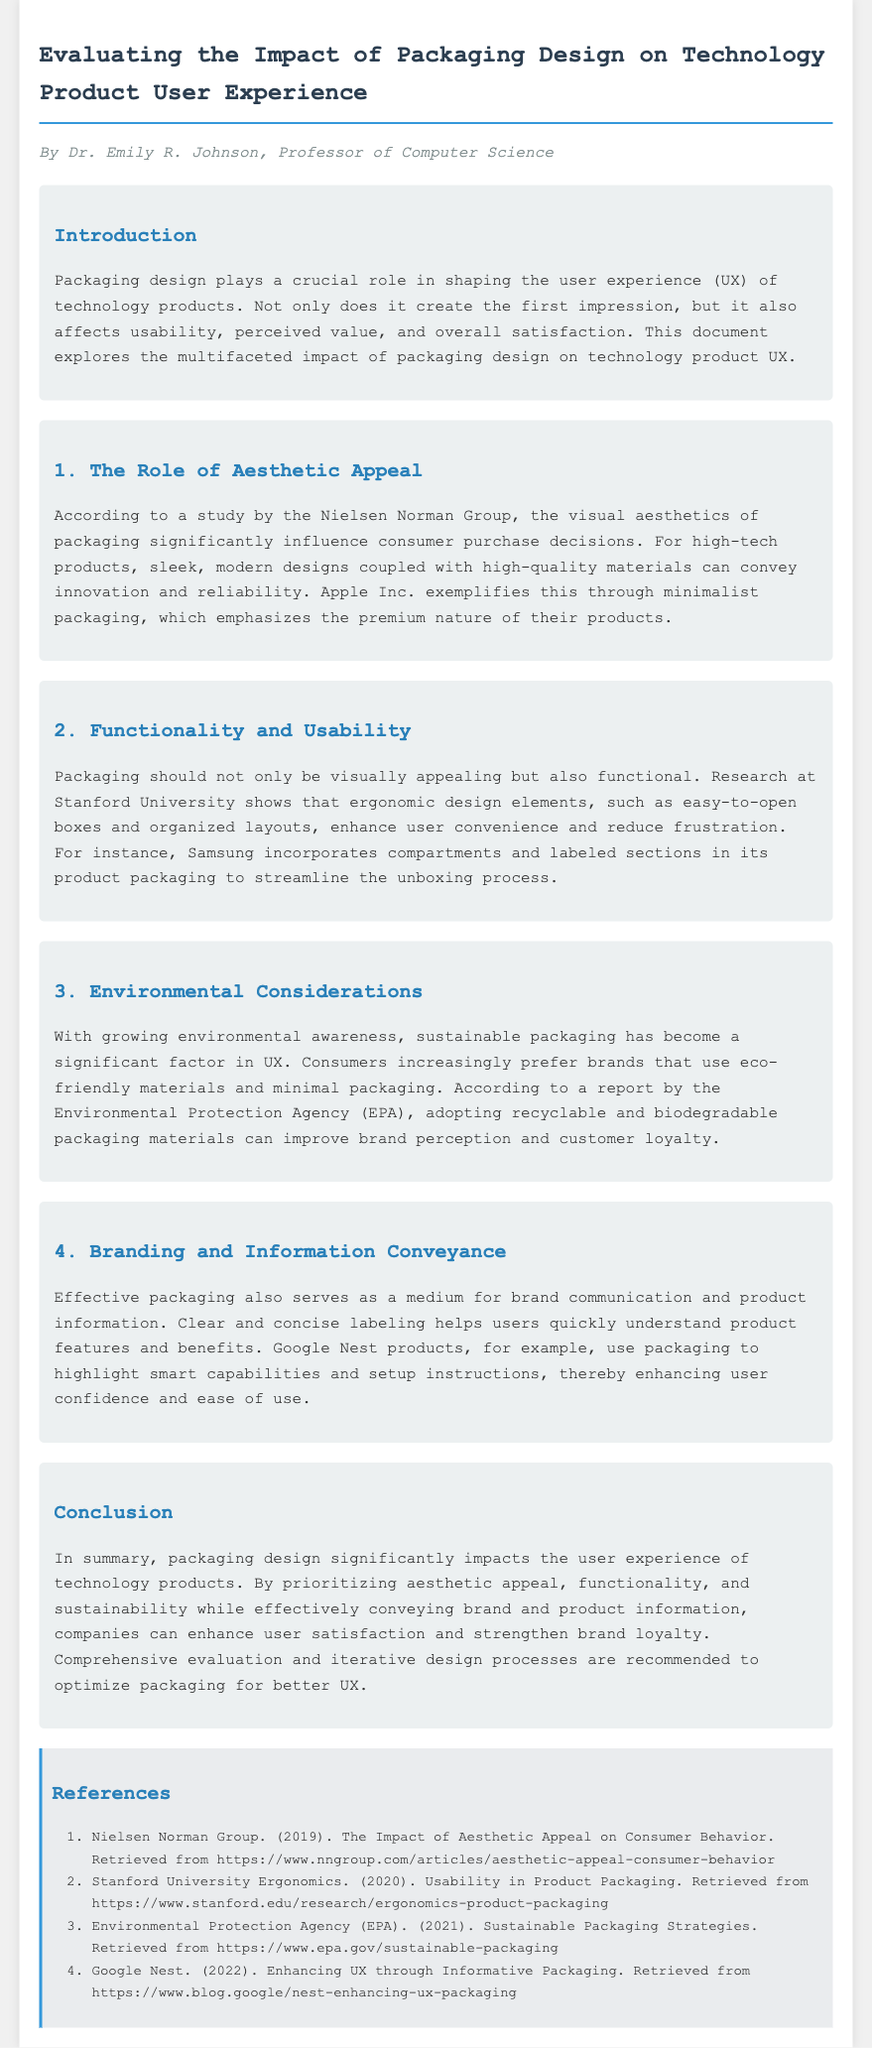What is the title of the document? The title can be found at the top of the document, indicating the main subject.
Answer: Evaluating the Impact of Packaging Design on Technology Product User Experience Who authored the document? The author's name is presented at the beginning, indicating their expertise.
Answer: Dr. Emily R. Johnson What is the focus of the introduction section? The introduction describes the importance of packaging design in shaping user experience.
Answer: The role of packaging design in shaping user experience What study is referenced for aesthetic appeal? A study is mentioned in the document that relates to the aesthetics of packaging and consumer behavior.
Answer: Nielsen Norman Group What year did the Environmental Protection Agency release their report on sustainable packaging? The document provides a citation including the year for the EPA report.
Answer: 2021 Which company's packaging is mentioned as an example of ergonomic design? An example from a well-known brand is cited in relation to organizational layout in packaging.
Answer: Samsung How does sustainable packaging affect consumer loyalty? The document discusses the perception of brands that use sustainable packaging.
Answer: Improve brand perception and customer loyalty What does Google Nest highlight in their packaging? The document indicates that specific information is communicated through packaging for certain tech products.
Answer: Smart capabilities and setup instructions What aspect does the conclusion emphasize about packaging design? The conclusion summarizes the main takeaways regarding the impact of design on user experience.
Answer: Impact of packaging design on user experience 